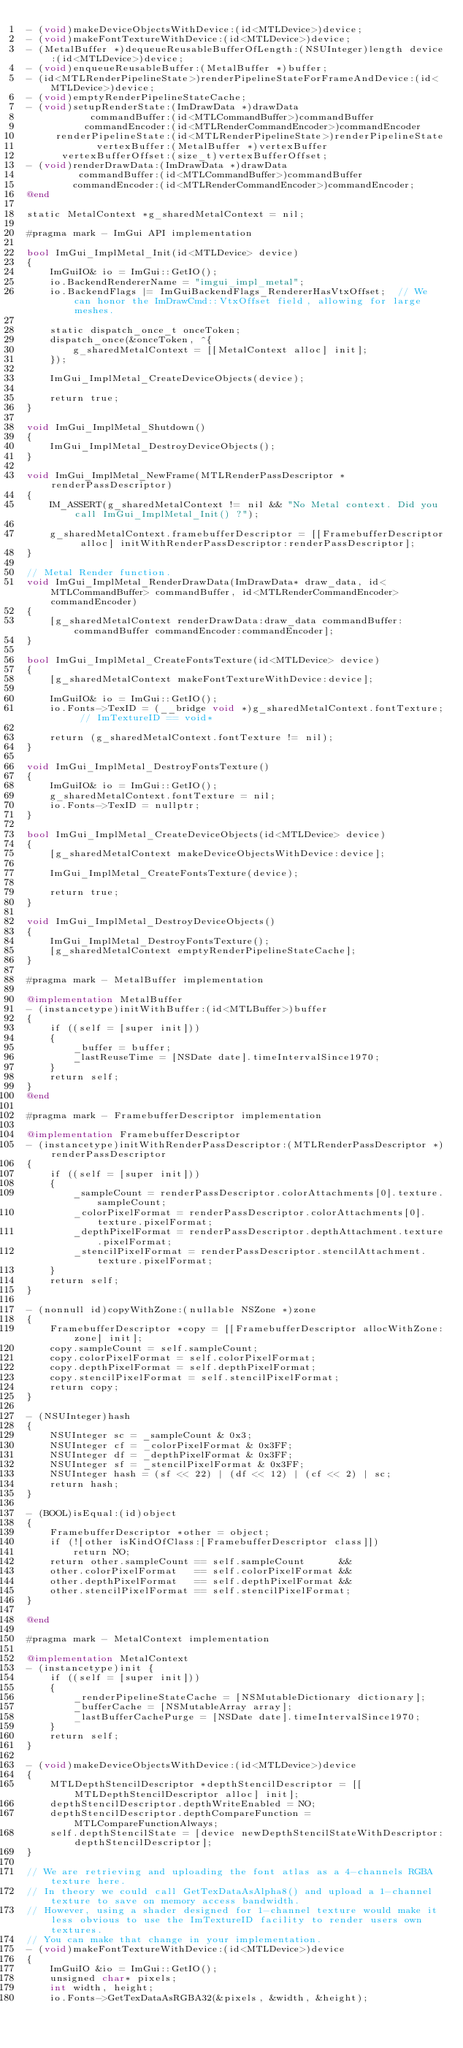Convert code to text. <code><loc_0><loc_0><loc_500><loc_500><_ObjectiveC_>- (void)makeDeviceObjectsWithDevice:(id<MTLDevice>)device;
- (void)makeFontTextureWithDevice:(id<MTLDevice>)device;
- (MetalBuffer *)dequeueReusableBufferOfLength:(NSUInteger)length device:(id<MTLDevice>)device;
- (void)enqueueReusableBuffer:(MetalBuffer *)buffer;
- (id<MTLRenderPipelineState>)renderPipelineStateForFrameAndDevice:(id<MTLDevice>)device;
- (void)emptyRenderPipelineStateCache;
- (void)setupRenderState:(ImDrawData *)drawData
           commandBuffer:(id<MTLCommandBuffer>)commandBuffer
          commandEncoder:(id<MTLRenderCommandEncoder>)commandEncoder
     renderPipelineState:(id<MTLRenderPipelineState>)renderPipelineState
            vertexBuffer:(MetalBuffer *)vertexBuffer
      vertexBufferOffset:(size_t)vertexBufferOffset;
- (void)renderDrawData:(ImDrawData *)drawData
         commandBuffer:(id<MTLCommandBuffer>)commandBuffer
        commandEncoder:(id<MTLRenderCommandEncoder>)commandEncoder;
@end

static MetalContext *g_sharedMetalContext = nil;

#pragma mark - ImGui API implementation

bool ImGui_ImplMetal_Init(id<MTLDevice> device)
{
    ImGuiIO& io = ImGui::GetIO();
    io.BackendRendererName = "imgui_impl_metal";
    io.BackendFlags |= ImGuiBackendFlags_RendererHasVtxOffset;  // We can honor the ImDrawCmd::VtxOffset field, allowing for large meshes.

    static dispatch_once_t onceToken;
    dispatch_once(&onceToken, ^{
        g_sharedMetalContext = [[MetalContext alloc] init];
    });

    ImGui_ImplMetal_CreateDeviceObjects(device);

    return true;
}

void ImGui_ImplMetal_Shutdown()
{
    ImGui_ImplMetal_DestroyDeviceObjects();
}

void ImGui_ImplMetal_NewFrame(MTLRenderPassDescriptor *renderPassDescriptor)
{
    IM_ASSERT(g_sharedMetalContext != nil && "No Metal context. Did you call ImGui_ImplMetal_Init() ?");

    g_sharedMetalContext.framebufferDescriptor = [[FramebufferDescriptor alloc] initWithRenderPassDescriptor:renderPassDescriptor];
}

// Metal Render function.
void ImGui_ImplMetal_RenderDrawData(ImDrawData* draw_data, id<MTLCommandBuffer> commandBuffer, id<MTLRenderCommandEncoder> commandEncoder)
{
    [g_sharedMetalContext renderDrawData:draw_data commandBuffer:commandBuffer commandEncoder:commandEncoder];
}

bool ImGui_ImplMetal_CreateFontsTexture(id<MTLDevice> device)
{
    [g_sharedMetalContext makeFontTextureWithDevice:device];

    ImGuiIO& io = ImGui::GetIO();
    io.Fonts->TexID = (__bridge void *)g_sharedMetalContext.fontTexture; // ImTextureID == void*

    return (g_sharedMetalContext.fontTexture != nil);
}

void ImGui_ImplMetal_DestroyFontsTexture()
{
    ImGuiIO& io = ImGui::GetIO();
    g_sharedMetalContext.fontTexture = nil;
    io.Fonts->TexID = nullptr;
}

bool ImGui_ImplMetal_CreateDeviceObjects(id<MTLDevice> device)
{
    [g_sharedMetalContext makeDeviceObjectsWithDevice:device];

    ImGui_ImplMetal_CreateFontsTexture(device);

    return true;
}

void ImGui_ImplMetal_DestroyDeviceObjects()
{
    ImGui_ImplMetal_DestroyFontsTexture();
    [g_sharedMetalContext emptyRenderPipelineStateCache];
}

#pragma mark - MetalBuffer implementation

@implementation MetalBuffer
- (instancetype)initWithBuffer:(id<MTLBuffer>)buffer
{
    if ((self = [super init]))
    {
        _buffer = buffer;
        _lastReuseTime = [NSDate date].timeIntervalSince1970;
    }
    return self;
}
@end

#pragma mark - FramebufferDescriptor implementation

@implementation FramebufferDescriptor
- (instancetype)initWithRenderPassDescriptor:(MTLRenderPassDescriptor *)renderPassDescriptor
{
    if ((self = [super init]))
    {
        _sampleCount = renderPassDescriptor.colorAttachments[0].texture.sampleCount;
        _colorPixelFormat = renderPassDescriptor.colorAttachments[0].texture.pixelFormat;
        _depthPixelFormat = renderPassDescriptor.depthAttachment.texture.pixelFormat;
        _stencilPixelFormat = renderPassDescriptor.stencilAttachment.texture.pixelFormat;
    }
    return self;
}

- (nonnull id)copyWithZone:(nullable NSZone *)zone
{
    FramebufferDescriptor *copy = [[FramebufferDescriptor allocWithZone:zone] init];
    copy.sampleCount = self.sampleCount;
    copy.colorPixelFormat = self.colorPixelFormat;
    copy.depthPixelFormat = self.depthPixelFormat;
    copy.stencilPixelFormat = self.stencilPixelFormat;
    return copy;
}

- (NSUInteger)hash
{
    NSUInteger sc = _sampleCount & 0x3;
    NSUInteger cf = _colorPixelFormat & 0x3FF;
    NSUInteger df = _depthPixelFormat & 0x3FF;
    NSUInteger sf = _stencilPixelFormat & 0x3FF;
    NSUInteger hash = (sf << 22) | (df << 12) | (cf << 2) | sc;
    return hash;
}

- (BOOL)isEqual:(id)object
{
    FramebufferDescriptor *other = object;
    if (![other isKindOfClass:[FramebufferDescriptor class]])
        return NO;
    return other.sampleCount == self.sampleCount      &&
    other.colorPixelFormat   == self.colorPixelFormat &&
    other.depthPixelFormat   == self.depthPixelFormat &&
    other.stencilPixelFormat == self.stencilPixelFormat;
}

@end

#pragma mark - MetalContext implementation

@implementation MetalContext
- (instancetype)init {
    if ((self = [super init]))
    {
        _renderPipelineStateCache = [NSMutableDictionary dictionary];
        _bufferCache = [NSMutableArray array];
        _lastBufferCachePurge = [NSDate date].timeIntervalSince1970;
    }
    return self;
}

- (void)makeDeviceObjectsWithDevice:(id<MTLDevice>)device
{
    MTLDepthStencilDescriptor *depthStencilDescriptor = [[MTLDepthStencilDescriptor alloc] init];
    depthStencilDescriptor.depthWriteEnabled = NO;
    depthStencilDescriptor.depthCompareFunction = MTLCompareFunctionAlways;
    self.depthStencilState = [device newDepthStencilStateWithDescriptor:depthStencilDescriptor];
}

// We are retrieving and uploading the font atlas as a 4-channels RGBA texture here.
// In theory we could call GetTexDataAsAlpha8() and upload a 1-channel texture to save on memory access bandwidth.
// However, using a shader designed for 1-channel texture would make it less obvious to use the ImTextureID facility to render users own textures.
// You can make that change in your implementation.
- (void)makeFontTextureWithDevice:(id<MTLDevice>)device
{
    ImGuiIO &io = ImGui::GetIO();
    unsigned char* pixels;
    int width, height;
    io.Fonts->GetTexDataAsRGBA32(&pixels, &width, &height);</code> 